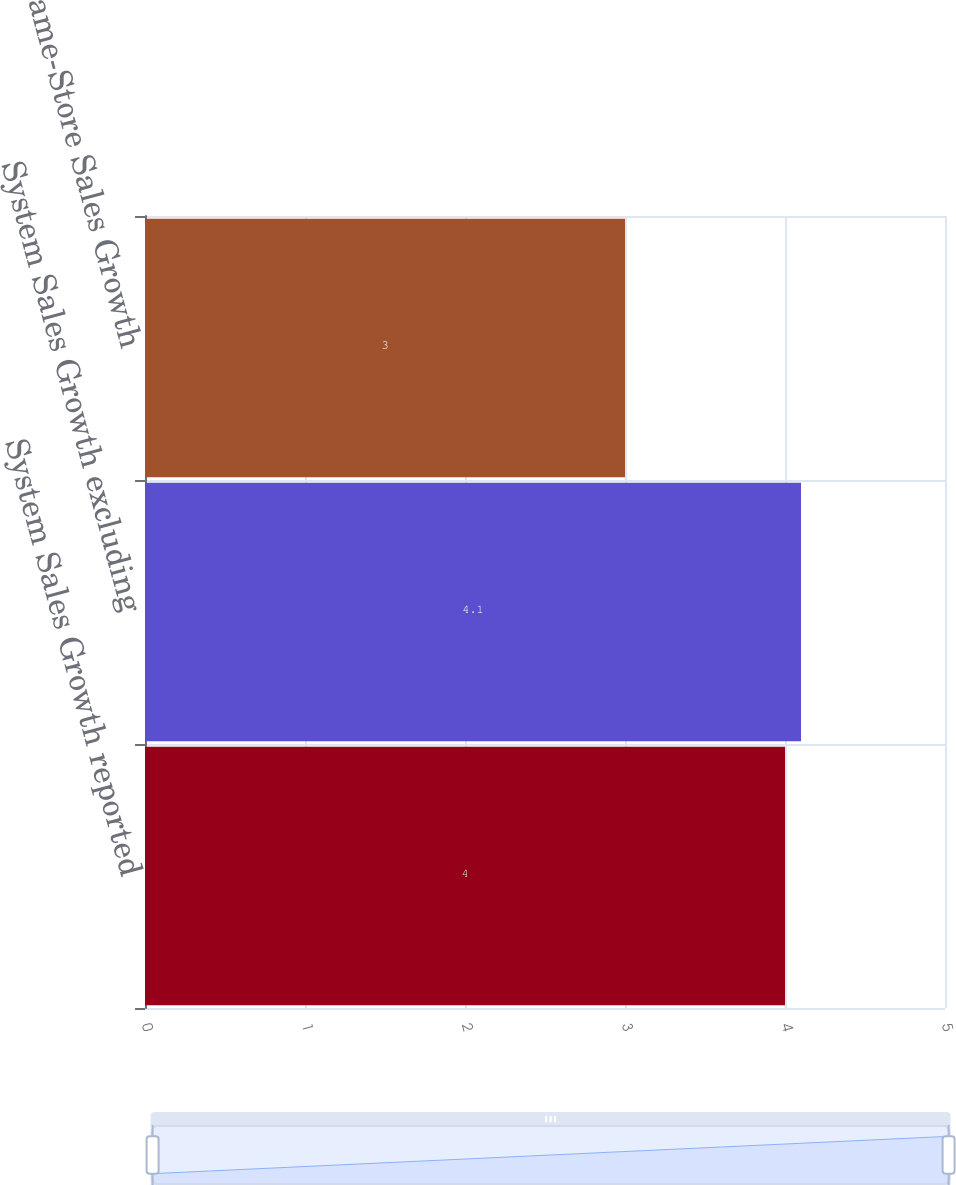<chart> <loc_0><loc_0><loc_500><loc_500><bar_chart><fcel>System Sales Growth reported<fcel>System Sales Growth excluding<fcel>Same-Store Sales Growth<nl><fcel>4<fcel>4.1<fcel>3<nl></chart> 